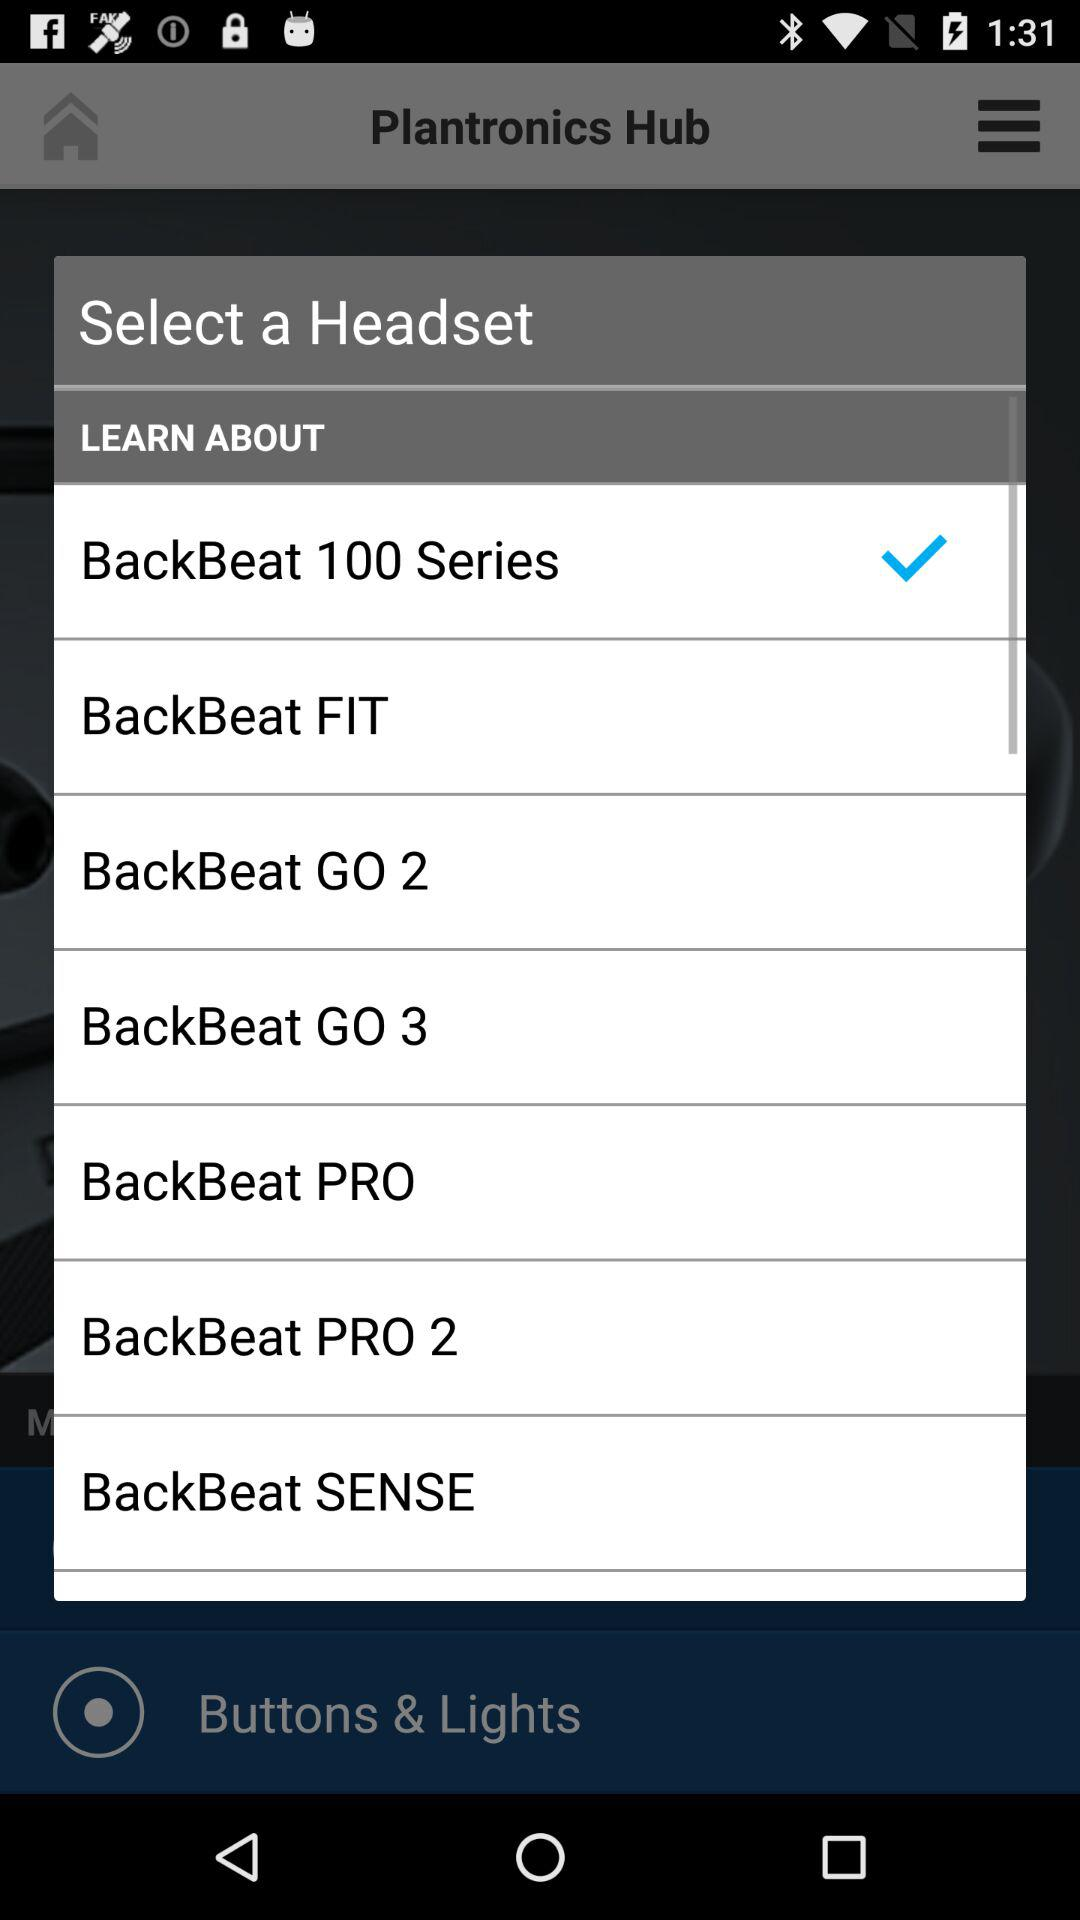Which headset is selected? The selected headset is "BackBeat 100 Series". 